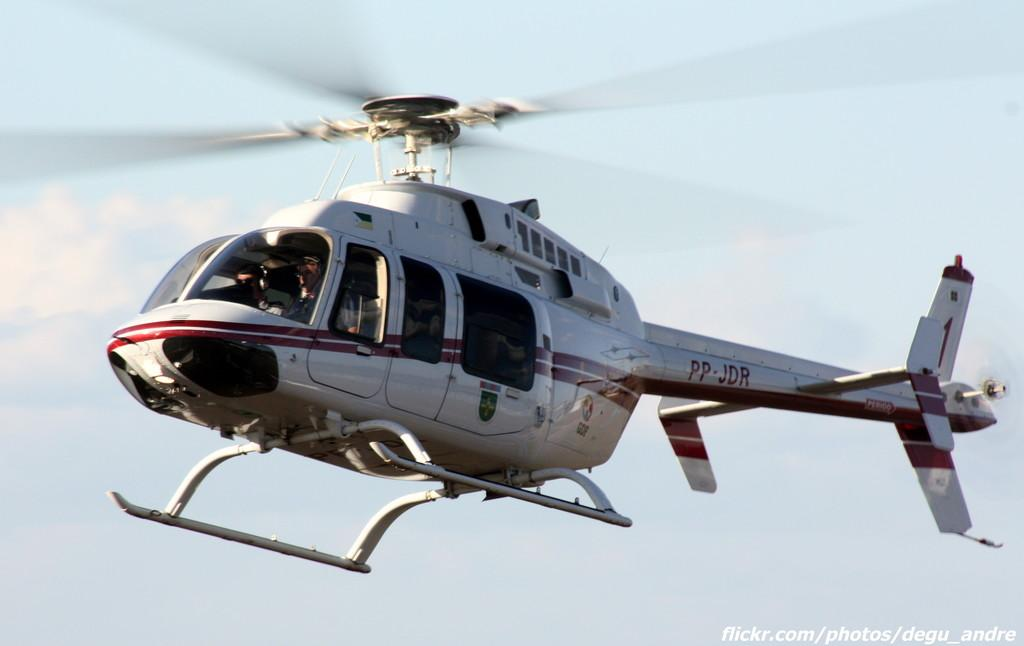<image>
Relay a brief, clear account of the picture shown. A helicopter that says PP JDR is flying in the sky. 